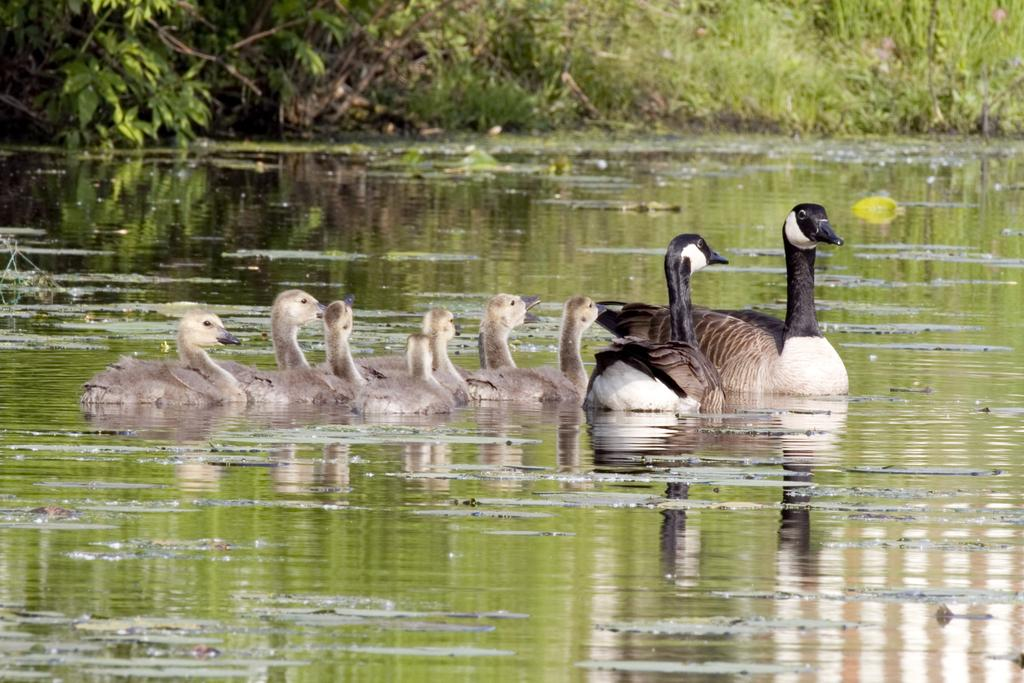What type of animals can be seen in the image? There are ducks in the image. What is the primary element in which the ducks are situated? The ducks are situated in water. What can be seen in the background of the image? There are plants in the background of the image. What type of jelly can be seen floating in the water in the image? There is no jelly present in the image; it features ducks in water with plants in the background. 